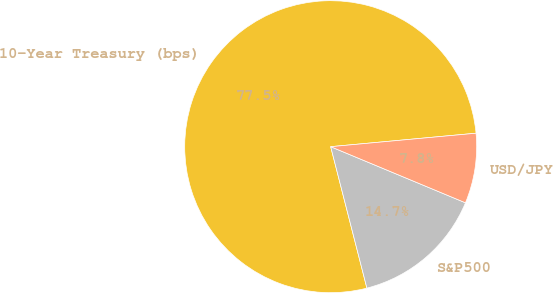Convert chart. <chart><loc_0><loc_0><loc_500><loc_500><pie_chart><fcel>10-Year Treasury (bps)<fcel>S&P500<fcel>USD/JPY<nl><fcel>77.52%<fcel>14.73%<fcel>7.75%<nl></chart> 